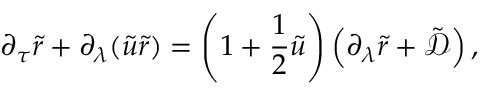Convert formula to latex. <formula><loc_0><loc_0><loc_500><loc_500>\partial _ { \tau } \tilde { r } + \partial _ { \lambda } ( \tilde { u } \tilde { r } ) = \left ( 1 + \frac { 1 } { 2 } \tilde { u } \right ) \left ( \partial _ { \lambda } \tilde { r } + \tilde { \mathcal { D } } \right ) ,</formula> 